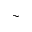Convert formula to latex. <formula><loc_0><loc_0><loc_500><loc_500>\sim</formula> 